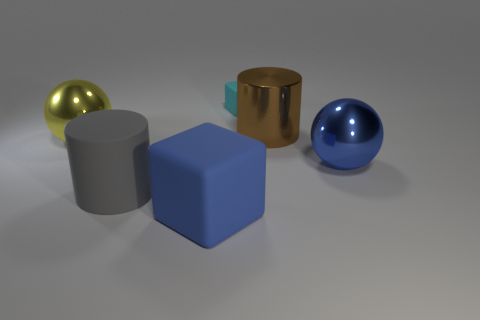Add 2 blue metal balls. How many objects exist? 8 Subtract all brown cylinders. How many cylinders are left? 1 Subtract all blocks. How many objects are left? 4 Subtract all large cylinders. Subtract all brown shiny things. How many objects are left? 3 Add 4 big rubber objects. How many big rubber objects are left? 6 Add 1 tiny red cylinders. How many tiny red cylinders exist? 1 Subtract 1 gray cylinders. How many objects are left? 5 Subtract all brown spheres. Subtract all green cylinders. How many spheres are left? 2 